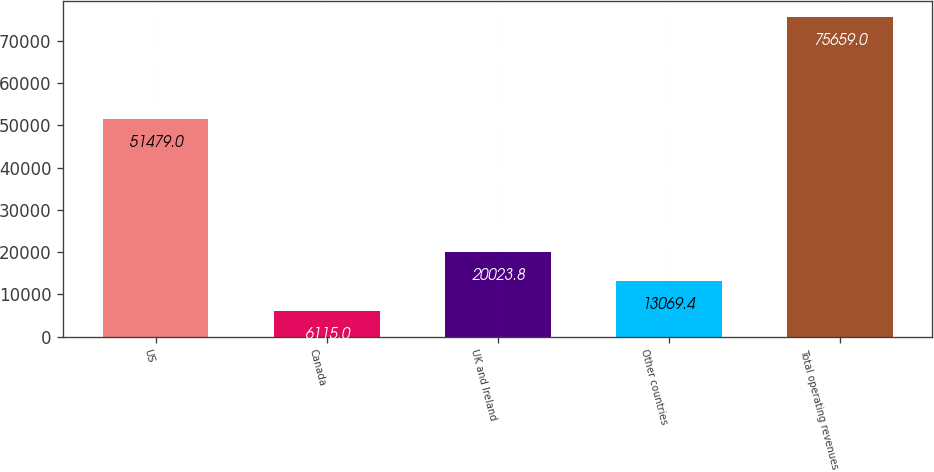Convert chart. <chart><loc_0><loc_0><loc_500><loc_500><bar_chart><fcel>US<fcel>Canada<fcel>UK and Ireland<fcel>Other countries<fcel>Total operating revenues<nl><fcel>51479<fcel>6115<fcel>20023.8<fcel>13069.4<fcel>75659<nl></chart> 